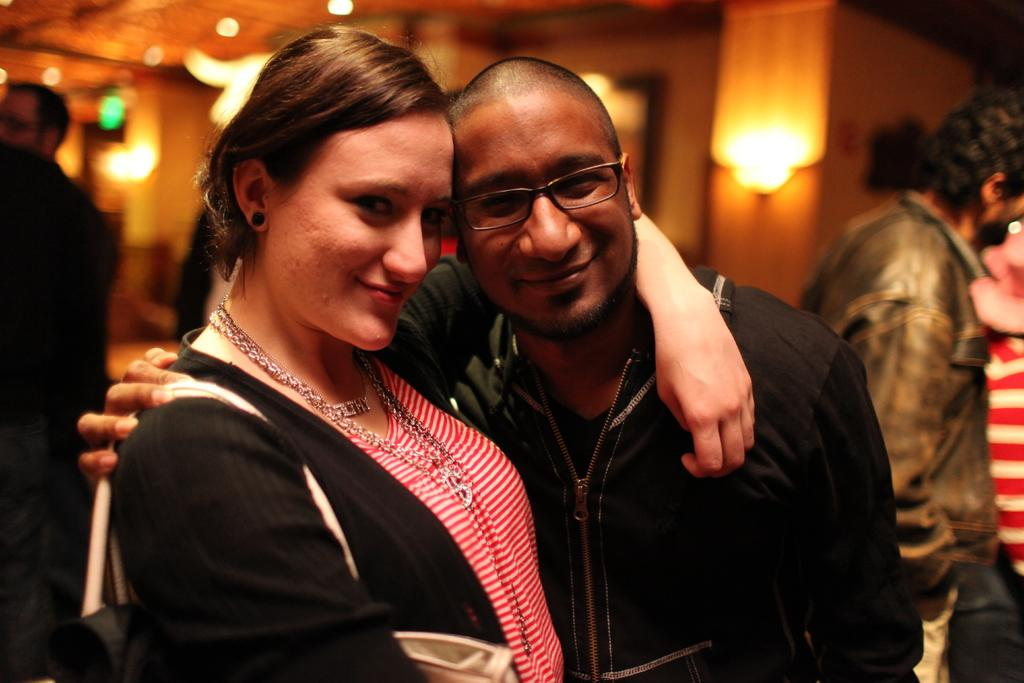Who are the main subjects in the foreground of the image? There is a woman and a man in the foreground of the image. Can you describe the background of the image? There are few persons and lights visible in the background of the image. What type of animal is being operated on in the image? There is no animal or operation present in the image. What thought is the woman having in the image? The image does not depict any thoughts or emotions of the woman; it only shows her physical presence. 